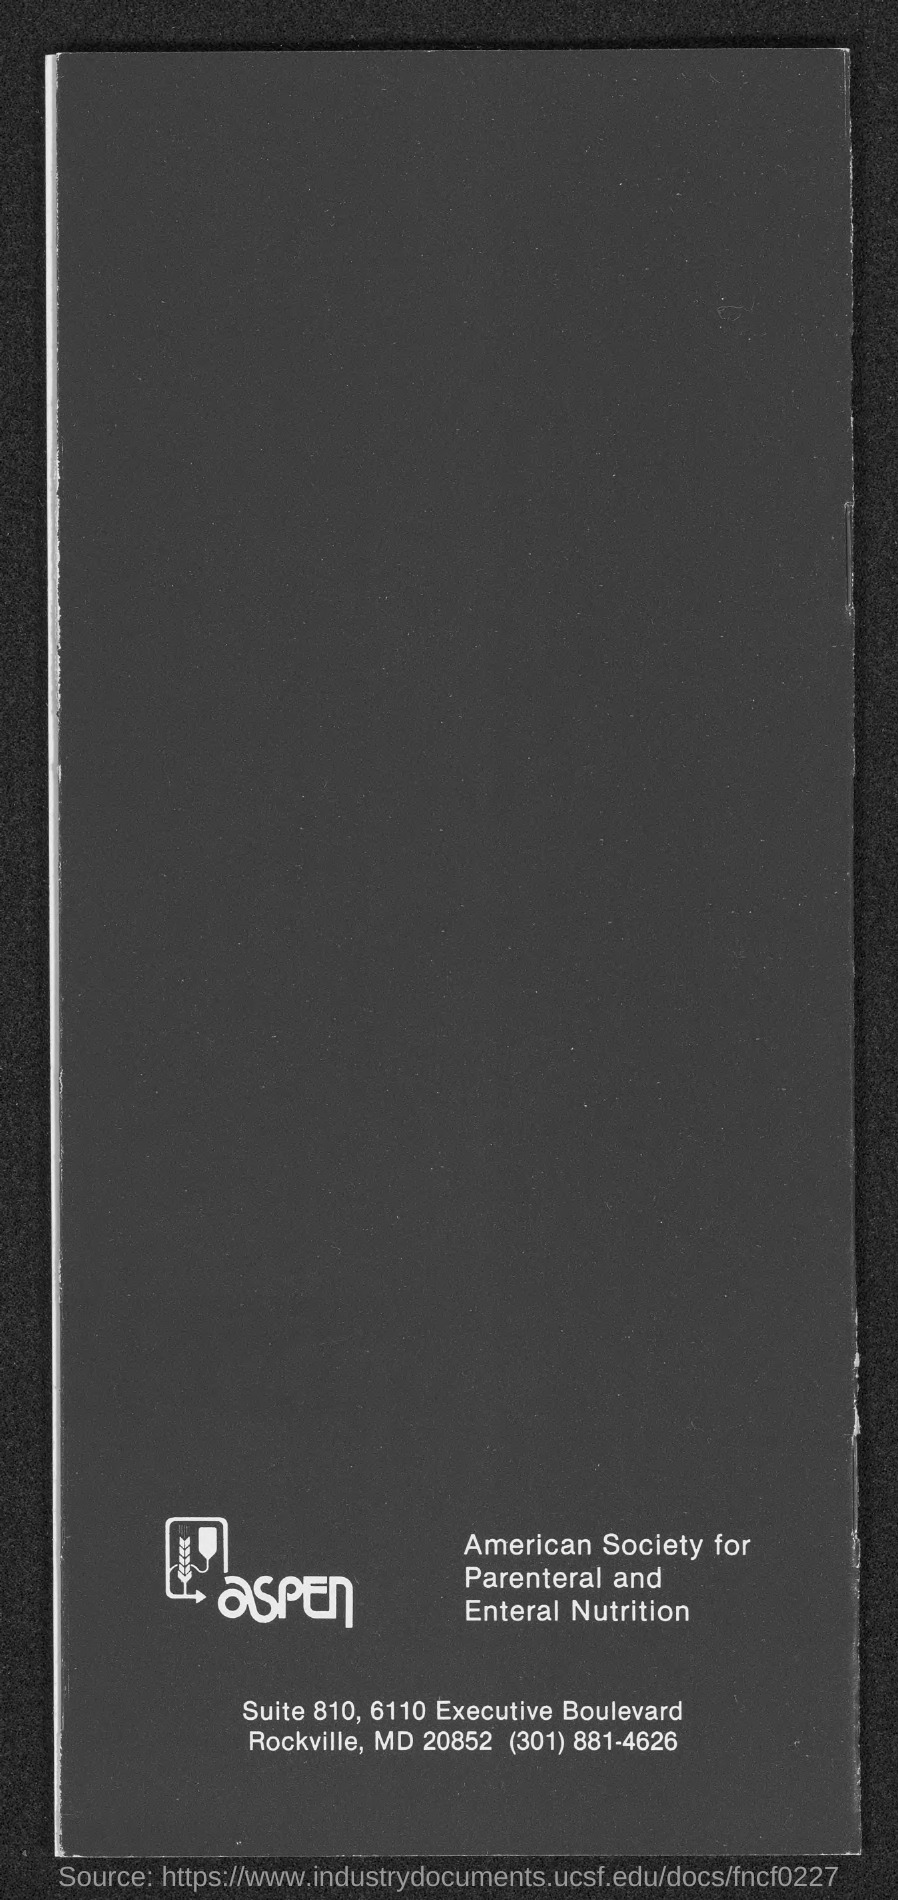Give some essential details in this illustration. The telephone number of the American Society for Parental and Enteral Nutrition is 301-881-4626. The street address of the American Society for Parental and Enteral Nutrition is located at Suite 810 at 6110 Executive Boulevard. 